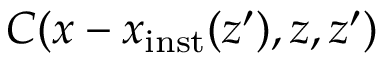Convert formula to latex. <formula><loc_0><loc_0><loc_500><loc_500>C ( x - x _ { i n s t } ( z ^ { \prime } ) , z , z ^ { \prime } )</formula> 